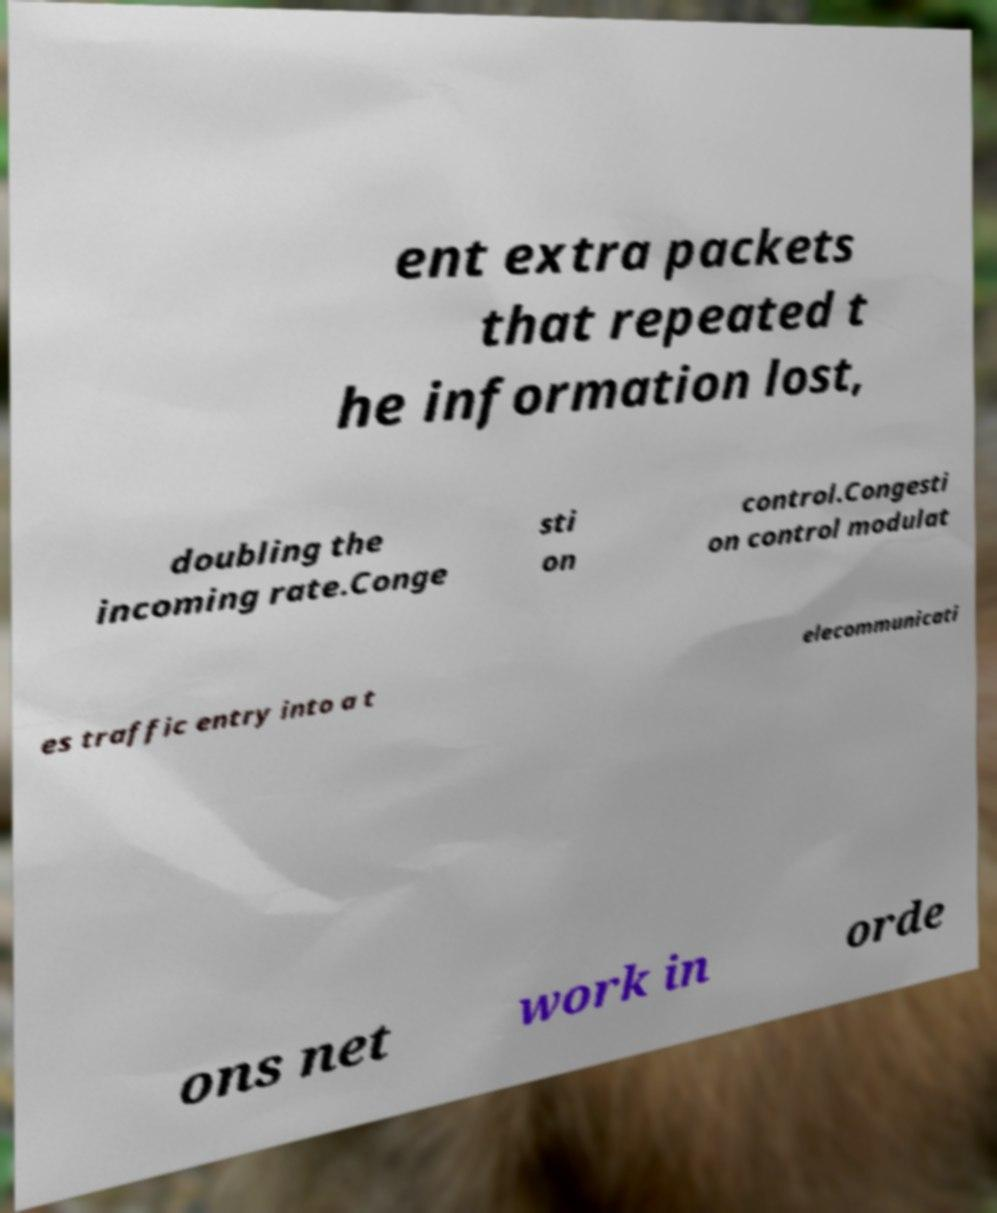Can you accurately transcribe the text from the provided image for me? ent extra packets that repeated t he information lost, doubling the incoming rate.Conge sti on control.Congesti on control modulat es traffic entry into a t elecommunicati ons net work in orde 